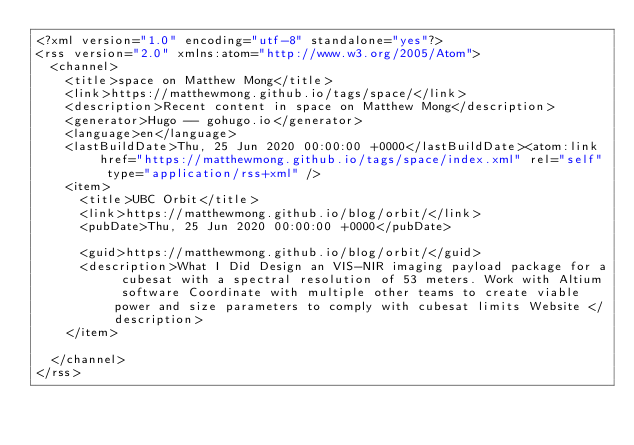<code> <loc_0><loc_0><loc_500><loc_500><_XML_><?xml version="1.0" encoding="utf-8" standalone="yes"?>
<rss version="2.0" xmlns:atom="http://www.w3.org/2005/Atom">
  <channel>
    <title>space on Matthew Mong</title>
    <link>https://matthewmong.github.io/tags/space/</link>
    <description>Recent content in space on Matthew Mong</description>
    <generator>Hugo -- gohugo.io</generator>
    <language>en</language>
    <lastBuildDate>Thu, 25 Jun 2020 00:00:00 +0000</lastBuildDate><atom:link href="https://matthewmong.github.io/tags/space/index.xml" rel="self" type="application/rss+xml" />
    <item>
      <title>UBC Orbit</title>
      <link>https://matthewmong.github.io/blog/orbit/</link>
      <pubDate>Thu, 25 Jun 2020 00:00:00 +0000</pubDate>
      
      <guid>https://matthewmong.github.io/blog/orbit/</guid>
      <description>What I Did Design an VIS-NIR imaging payload package for a cubesat with a spectral resolution of 53 meters. Work with Altium software Coordinate with multiple other teams to create viable power and size parameters to comply with cubesat limits Website </description>
    </item>
    
  </channel>
</rss>
</code> 